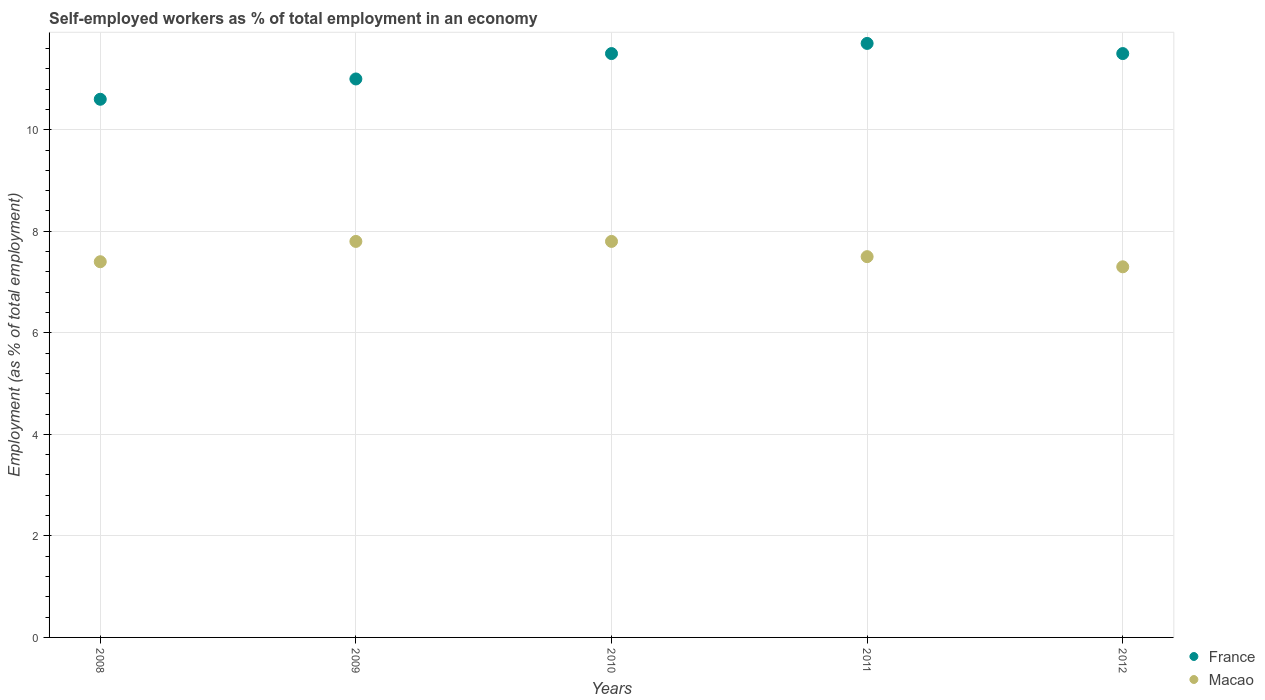What is the percentage of self-employed workers in France in 2009?
Offer a terse response. 11. Across all years, what is the maximum percentage of self-employed workers in France?
Your answer should be very brief. 11.7. Across all years, what is the minimum percentage of self-employed workers in France?
Keep it short and to the point. 10.6. In which year was the percentage of self-employed workers in Macao maximum?
Offer a very short reply. 2009. In which year was the percentage of self-employed workers in Macao minimum?
Your answer should be very brief. 2012. What is the total percentage of self-employed workers in France in the graph?
Your response must be concise. 56.3. What is the difference between the percentage of self-employed workers in Macao in 2009 and that in 2012?
Offer a very short reply. 0.5. What is the difference between the percentage of self-employed workers in France in 2011 and the percentage of self-employed workers in Macao in 2009?
Your response must be concise. 3.9. What is the average percentage of self-employed workers in France per year?
Provide a succinct answer. 11.26. In the year 2012, what is the difference between the percentage of self-employed workers in Macao and percentage of self-employed workers in France?
Offer a terse response. -4.2. In how many years, is the percentage of self-employed workers in France greater than 4.4 %?
Provide a short and direct response. 5. What is the ratio of the percentage of self-employed workers in Macao in 2009 to that in 2011?
Offer a terse response. 1.04. Is the percentage of self-employed workers in France in 2009 less than that in 2010?
Provide a short and direct response. Yes. What is the difference between the highest and the second highest percentage of self-employed workers in France?
Provide a succinct answer. 0.2. What is the difference between the highest and the lowest percentage of self-employed workers in France?
Keep it short and to the point. 1.1. In how many years, is the percentage of self-employed workers in Macao greater than the average percentage of self-employed workers in Macao taken over all years?
Your answer should be very brief. 2. Does the percentage of self-employed workers in France monotonically increase over the years?
Provide a short and direct response. No. Is the percentage of self-employed workers in Macao strictly less than the percentage of self-employed workers in France over the years?
Your response must be concise. Yes. Are the values on the major ticks of Y-axis written in scientific E-notation?
Your response must be concise. No. Where does the legend appear in the graph?
Your answer should be compact. Bottom right. How many legend labels are there?
Your answer should be very brief. 2. How are the legend labels stacked?
Make the answer very short. Vertical. What is the title of the graph?
Provide a succinct answer. Self-employed workers as % of total employment in an economy. What is the label or title of the Y-axis?
Your answer should be compact. Employment (as % of total employment). What is the Employment (as % of total employment) in France in 2008?
Give a very brief answer. 10.6. What is the Employment (as % of total employment) of Macao in 2008?
Ensure brevity in your answer.  7.4. What is the Employment (as % of total employment) in Macao in 2009?
Offer a terse response. 7.8. What is the Employment (as % of total employment) of France in 2010?
Your response must be concise. 11.5. What is the Employment (as % of total employment) of Macao in 2010?
Your answer should be very brief. 7.8. What is the Employment (as % of total employment) in France in 2011?
Your answer should be very brief. 11.7. What is the Employment (as % of total employment) in Macao in 2011?
Give a very brief answer. 7.5. What is the Employment (as % of total employment) of France in 2012?
Provide a short and direct response. 11.5. What is the Employment (as % of total employment) in Macao in 2012?
Give a very brief answer. 7.3. Across all years, what is the maximum Employment (as % of total employment) of France?
Your answer should be very brief. 11.7. Across all years, what is the maximum Employment (as % of total employment) of Macao?
Provide a short and direct response. 7.8. Across all years, what is the minimum Employment (as % of total employment) of France?
Offer a very short reply. 10.6. Across all years, what is the minimum Employment (as % of total employment) of Macao?
Provide a succinct answer. 7.3. What is the total Employment (as % of total employment) of France in the graph?
Make the answer very short. 56.3. What is the total Employment (as % of total employment) in Macao in the graph?
Offer a terse response. 37.8. What is the difference between the Employment (as % of total employment) in France in 2008 and that in 2009?
Ensure brevity in your answer.  -0.4. What is the difference between the Employment (as % of total employment) in Macao in 2008 and that in 2011?
Make the answer very short. -0.1. What is the difference between the Employment (as % of total employment) in Macao in 2009 and that in 2010?
Ensure brevity in your answer.  0. What is the difference between the Employment (as % of total employment) of Macao in 2009 and that in 2011?
Your answer should be compact. 0.3. What is the difference between the Employment (as % of total employment) in France in 2009 and that in 2012?
Give a very brief answer. -0.5. What is the difference between the Employment (as % of total employment) of France in 2008 and the Employment (as % of total employment) of Macao in 2010?
Ensure brevity in your answer.  2.8. What is the difference between the Employment (as % of total employment) of France in 2008 and the Employment (as % of total employment) of Macao in 2011?
Make the answer very short. 3.1. What is the difference between the Employment (as % of total employment) in France in 2009 and the Employment (as % of total employment) in Macao in 2012?
Provide a succinct answer. 3.7. What is the average Employment (as % of total employment) in France per year?
Give a very brief answer. 11.26. What is the average Employment (as % of total employment) of Macao per year?
Your answer should be very brief. 7.56. What is the ratio of the Employment (as % of total employment) of France in 2008 to that in 2009?
Offer a very short reply. 0.96. What is the ratio of the Employment (as % of total employment) of Macao in 2008 to that in 2009?
Give a very brief answer. 0.95. What is the ratio of the Employment (as % of total employment) of France in 2008 to that in 2010?
Offer a terse response. 0.92. What is the ratio of the Employment (as % of total employment) in Macao in 2008 to that in 2010?
Keep it short and to the point. 0.95. What is the ratio of the Employment (as % of total employment) in France in 2008 to that in 2011?
Your response must be concise. 0.91. What is the ratio of the Employment (as % of total employment) of Macao in 2008 to that in 2011?
Your answer should be compact. 0.99. What is the ratio of the Employment (as % of total employment) of France in 2008 to that in 2012?
Offer a terse response. 0.92. What is the ratio of the Employment (as % of total employment) in Macao in 2008 to that in 2012?
Offer a terse response. 1.01. What is the ratio of the Employment (as % of total employment) of France in 2009 to that in 2010?
Provide a succinct answer. 0.96. What is the ratio of the Employment (as % of total employment) in Macao in 2009 to that in 2010?
Ensure brevity in your answer.  1. What is the ratio of the Employment (as % of total employment) of France in 2009 to that in 2011?
Make the answer very short. 0.94. What is the ratio of the Employment (as % of total employment) of Macao in 2009 to that in 2011?
Offer a terse response. 1.04. What is the ratio of the Employment (as % of total employment) in France in 2009 to that in 2012?
Your answer should be compact. 0.96. What is the ratio of the Employment (as % of total employment) in Macao in 2009 to that in 2012?
Offer a very short reply. 1.07. What is the ratio of the Employment (as % of total employment) of France in 2010 to that in 2011?
Keep it short and to the point. 0.98. What is the ratio of the Employment (as % of total employment) in Macao in 2010 to that in 2011?
Your response must be concise. 1.04. What is the ratio of the Employment (as % of total employment) in Macao in 2010 to that in 2012?
Offer a very short reply. 1.07. What is the ratio of the Employment (as % of total employment) of France in 2011 to that in 2012?
Offer a terse response. 1.02. What is the ratio of the Employment (as % of total employment) of Macao in 2011 to that in 2012?
Your response must be concise. 1.03. What is the difference between the highest and the second highest Employment (as % of total employment) of France?
Your answer should be compact. 0.2. What is the difference between the highest and the second highest Employment (as % of total employment) in Macao?
Provide a succinct answer. 0. 